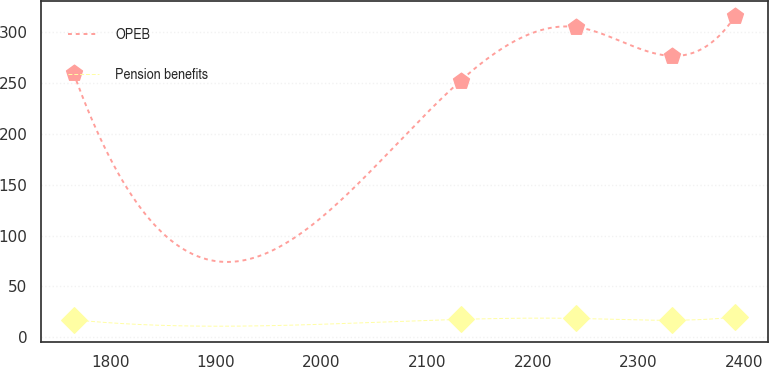<chart> <loc_0><loc_0><loc_500><loc_500><line_chart><ecel><fcel>OPEB<fcel>Pension benefits<nl><fcel>1765.54<fcel>259.65<fcel>17.14<nl><fcel>2131.8<fcel>252.43<fcel>17.54<nl><fcel>2240.75<fcel>305.24<fcel>18.48<nl><fcel>2331.79<fcel>276.81<fcel>16.68<nl><fcel>2391.57<fcel>315.79<fcel>19.88<nl></chart> 